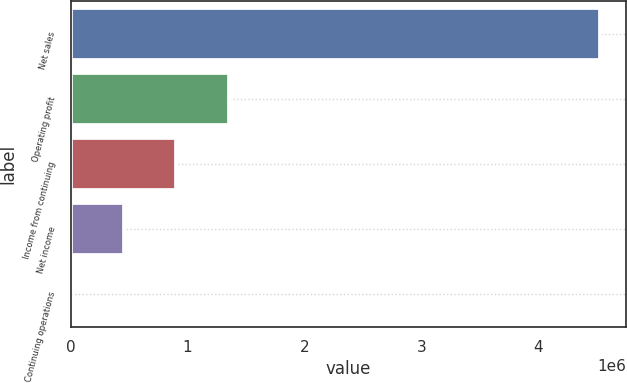<chart> <loc_0><loc_0><loc_500><loc_500><bar_chart><fcel>Net sales<fcel>Operating profit<fcel>Income from continuing<fcel>Net income<fcel>Continuing operations<nl><fcel>4.52572e+06<fcel>1.35772e+06<fcel>905146<fcel>452574<fcel>2.35<nl></chart> 